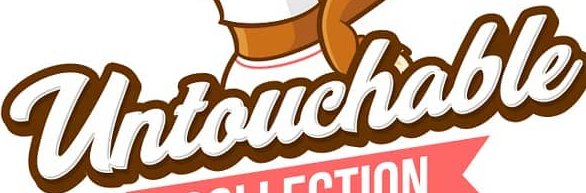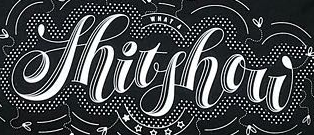What text appears in these images from left to right, separated by a semicolon? Untouchable; Shitshow 